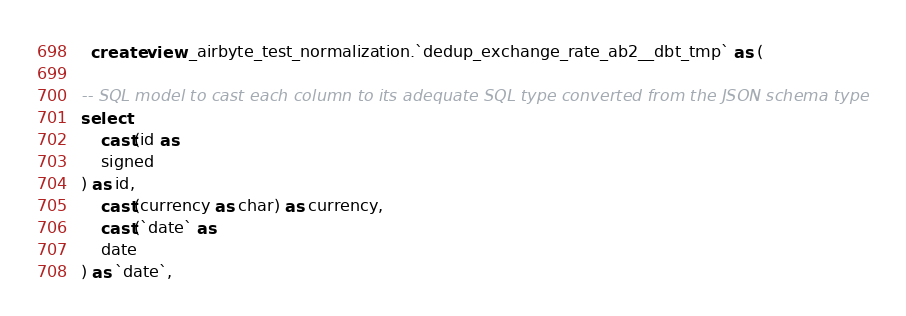Convert code to text. <code><loc_0><loc_0><loc_500><loc_500><_SQL_>
  create view _airbyte_test_normalization.`dedup_exchange_rate_ab2__dbt_tmp` as (
    
-- SQL model to cast each column to its adequate SQL type converted from the JSON schema type
select
    cast(id as 
    signed
) as id,
    cast(currency as char) as currency,
    cast(`date` as 
    date
) as `date`,</code> 